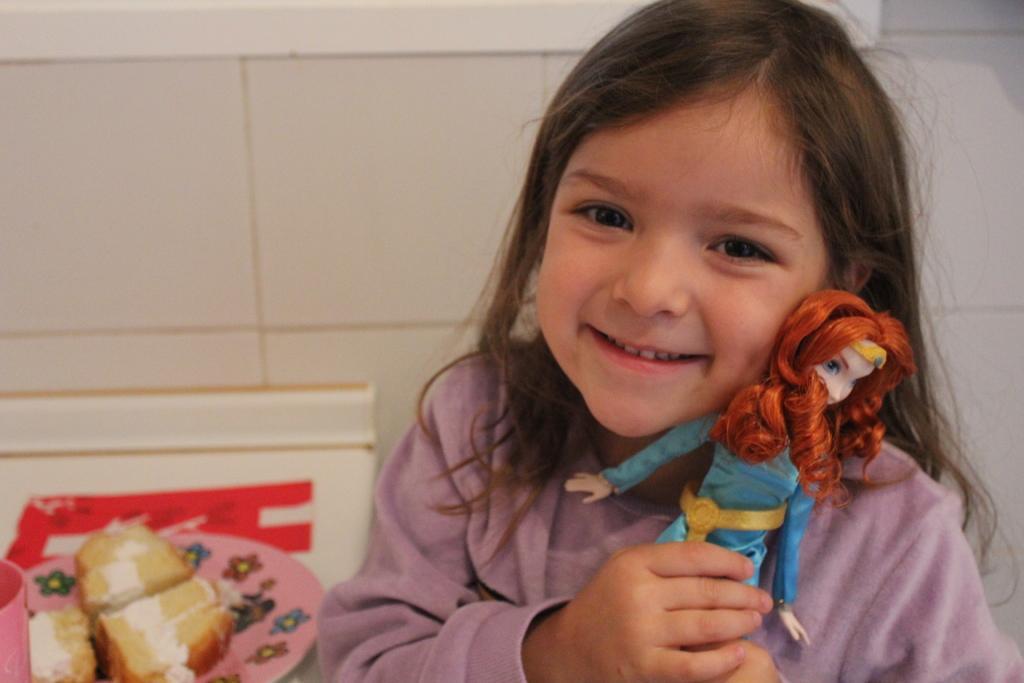Could you give a brief overview of what you see in this image? In this picture I can see a girl in front who is holding a doll in her hands and I see that she is smiling. In the background I see the wall and on the left bottom of this image I see a plate on which there is food. 